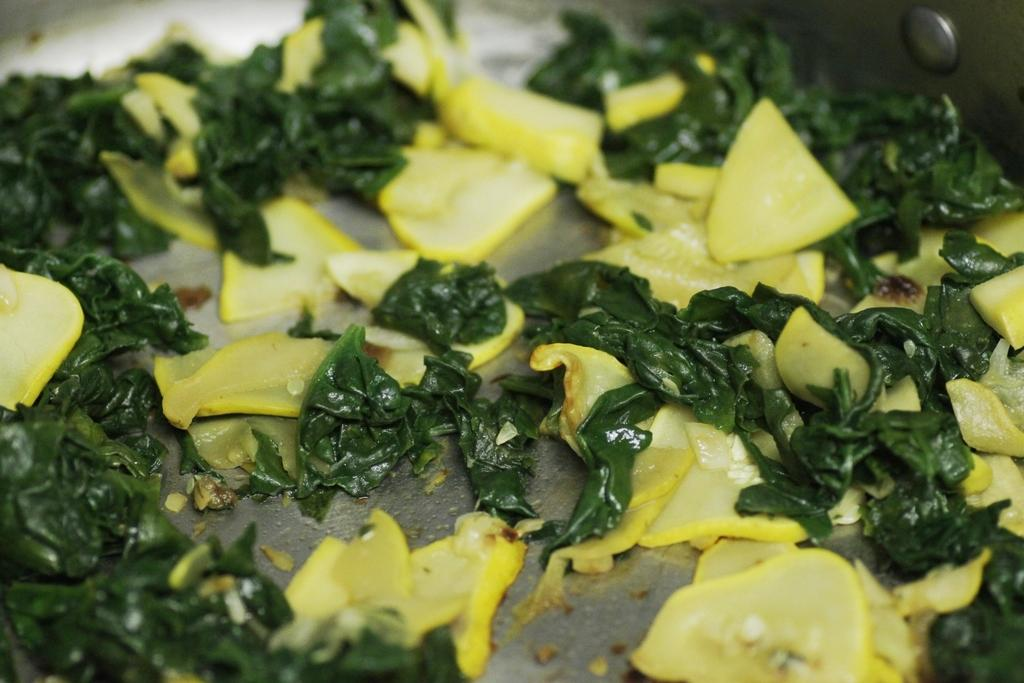What is the main subject of the image? The main subject of the image is food. Can you describe the colors of the food? The food has yellow and green colors. What type of shoe is being used to prepare the food in the image? There is no shoe present in the image; it features food with yellow and green colors. How is the thread being used in the food preparation process in the image? There is no thread present in the image; it features food with yellow and green colors. 